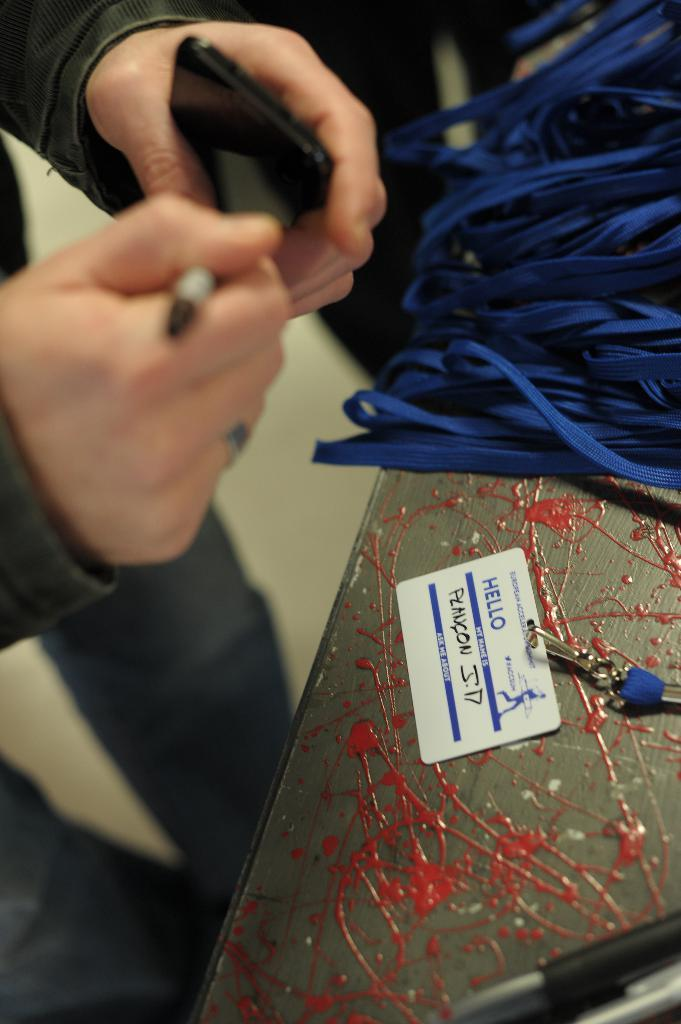What are the men in the image doing? The men in the image are standing and holding mobile phones. What objects can be seen in the men's hands? The men are holding mobile phones. What is on the table in the image? There are blue color ropes and a card with text on the table. Can you tell me how many tails are visible in the image? There are no tails visible in the image. Is there a lake in the background of the image? There is no lake present in the image. 